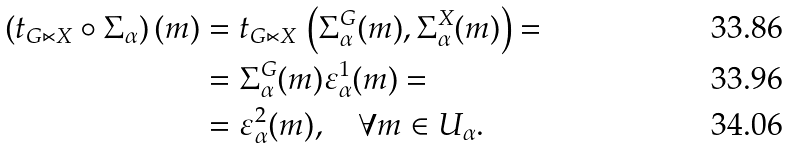<formula> <loc_0><loc_0><loc_500><loc_500>\left ( t _ { G \ltimes X } \circ \Sigma _ { \alpha } \right ) ( m ) & = t _ { G \ltimes X } \, \left ( \Sigma _ { \alpha } ^ { G } ( m ) , \Sigma _ { \alpha } ^ { X } ( m ) \right ) = \\ & = \Sigma _ { \alpha } ^ { G } ( m ) \varepsilon _ { \alpha } ^ { 1 } ( m ) = \\ & = \varepsilon _ { \alpha } ^ { 2 } ( m ) , \quad \forall m \in U _ { \alpha } .</formula> 